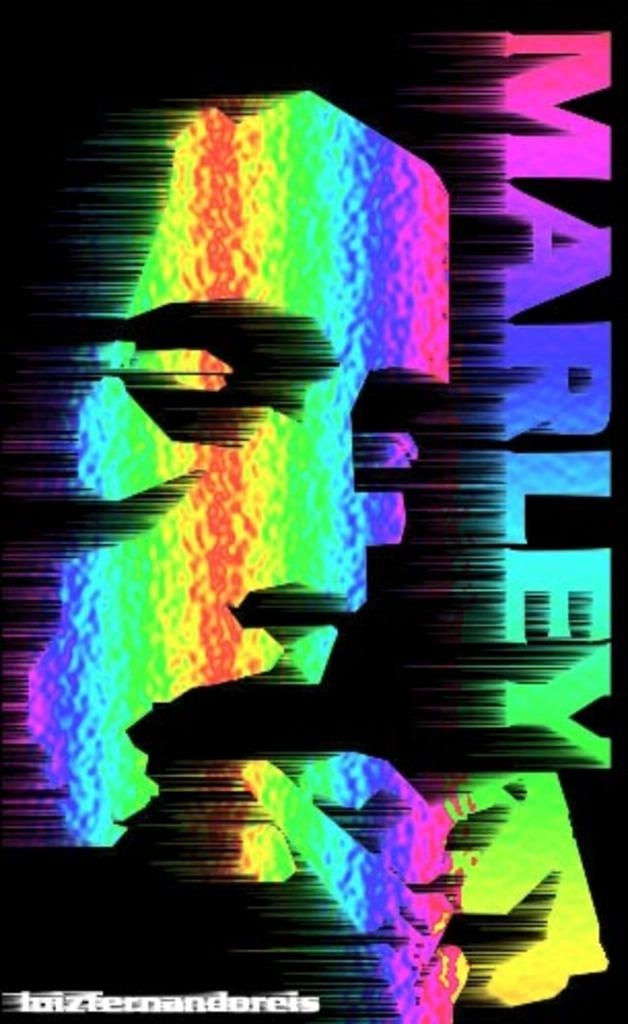<image>
Describe the image concisely. a colorful poster that says the word 'marley' on it 